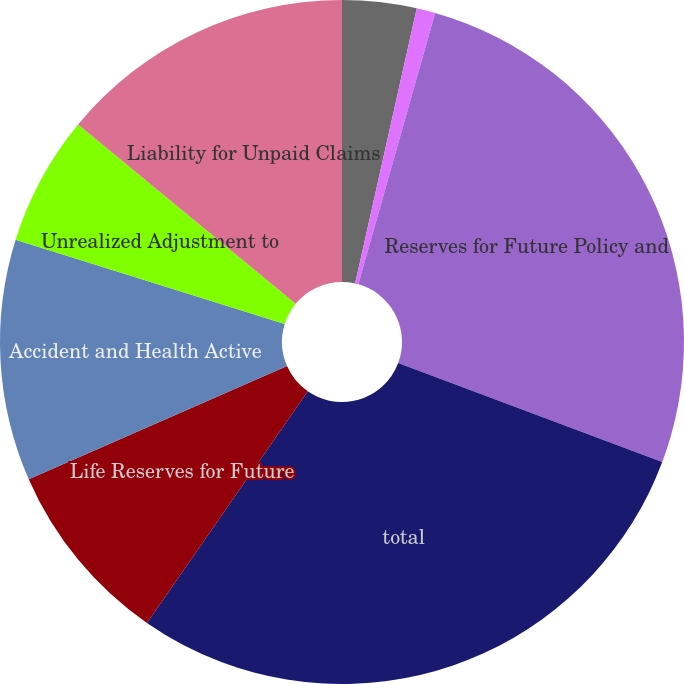Convert chart to OTSL. <chart><loc_0><loc_0><loc_500><loc_500><pie_chart><fcel>(in millions of dollars)<fcel>Policy and Contract Benefits<fcel>Reserves for Future Policy and<fcel>total<fcel>Life Reserves for Future<fcel>Accident and Health Active<fcel>Unrealized Adjustment to<fcel>Liability for Unpaid Claims<nl><fcel>3.51%<fcel>0.88%<fcel>26.32%<fcel>28.95%<fcel>8.77%<fcel>11.4%<fcel>6.14%<fcel>14.03%<nl></chart> 